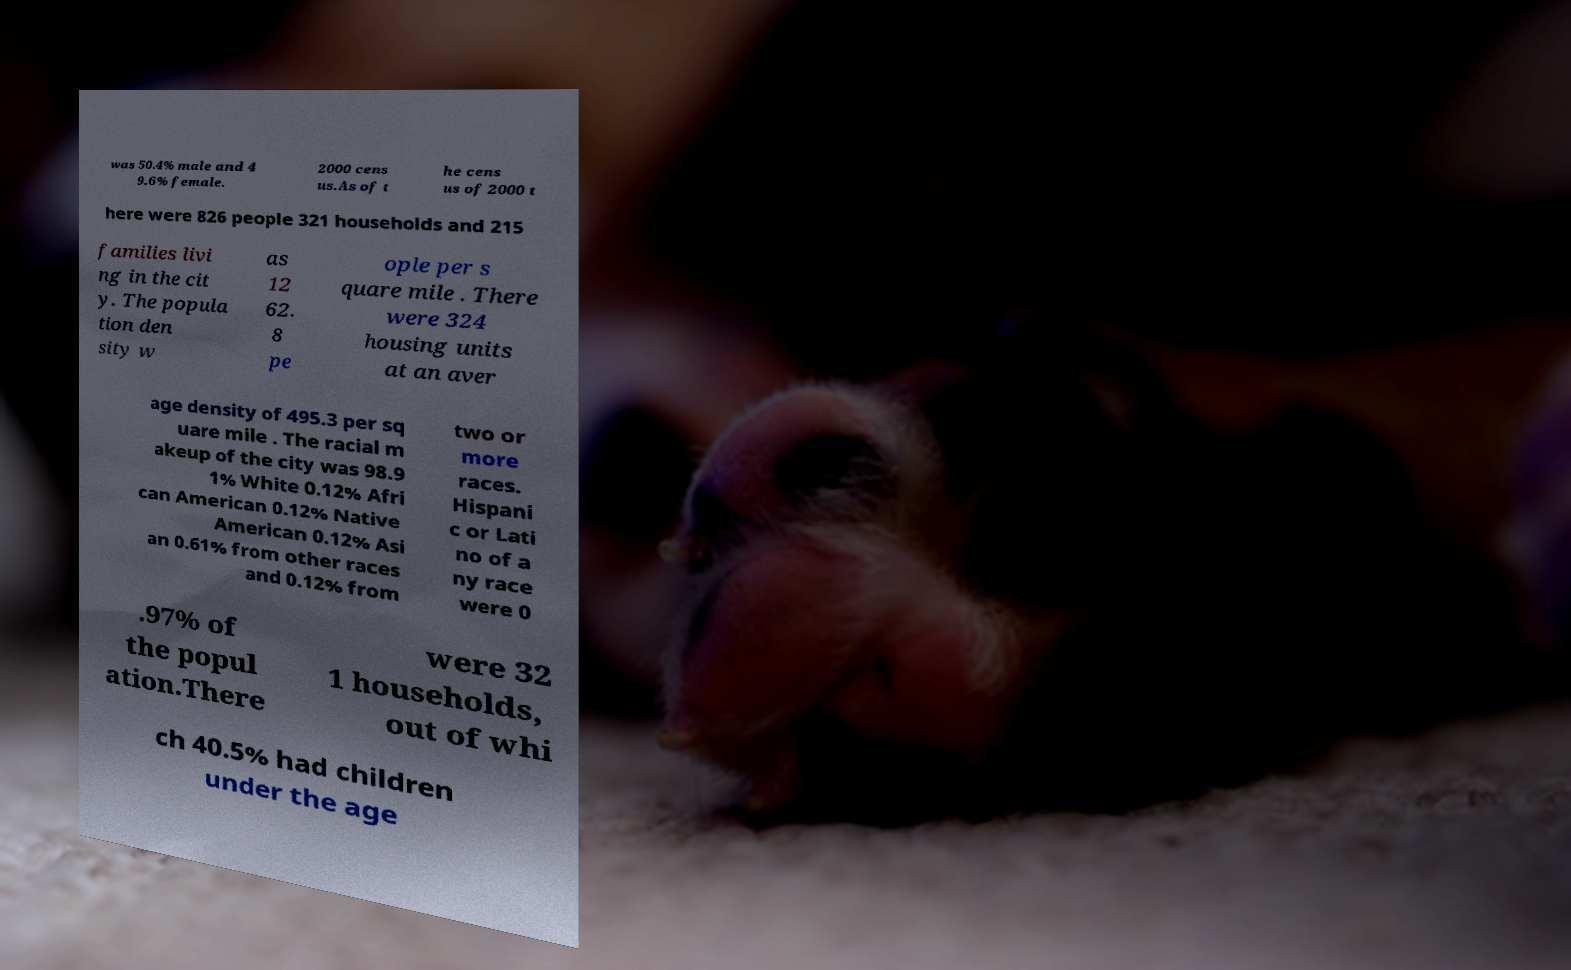Could you extract and type out the text from this image? was 50.4% male and 4 9.6% female. 2000 cens us.As of t he cens us of 2000 t here were 826 people 321 households and 215 families livi ng in the cit y. The popula tion den sity w as 12 62. 8 pe ople per s quare mile . There were 324 housing units at an aver age density of 495.3 per sq uare mile . The racial m akeup of the city was 98.9 1% White 0.12% Afri can American 0.12% Native American 0.12% Asi an 0.61% from other races and 0.12% from two or more races. Hispani c or Lati no of a ny race were 0 .97% of the popul ation.There were 32 1 households, out of whi ch 40.5% had children under the age 